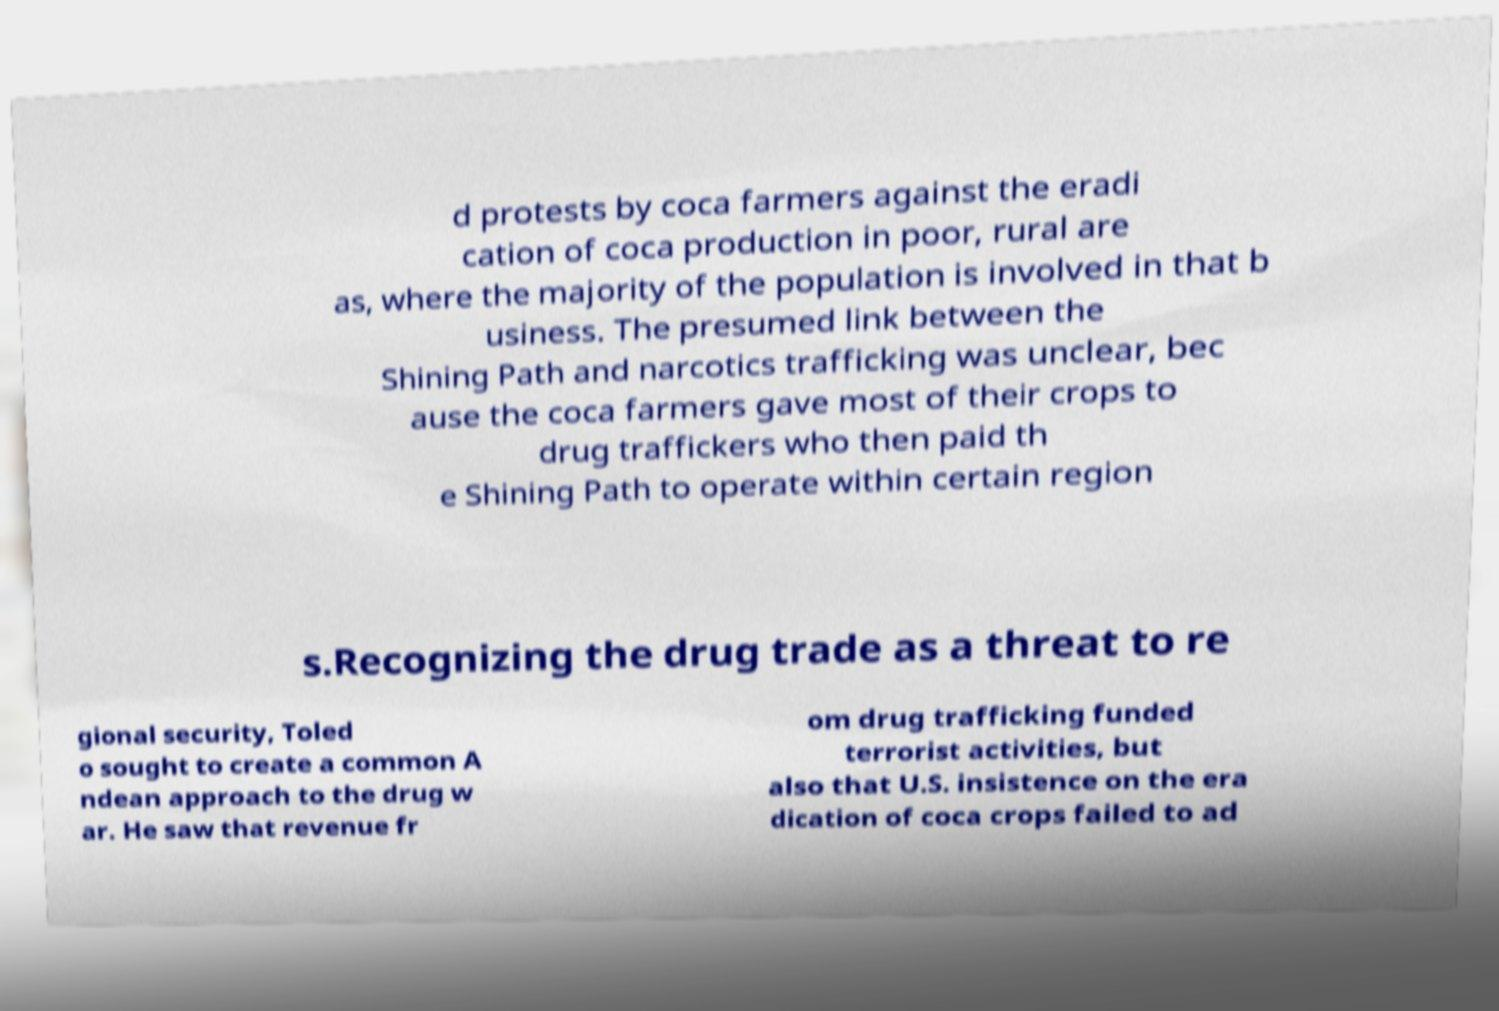Can you read and provide the text displayed in the image?This photo seems to have some interesting text. Can you extract and type it out for me? d protests by coca farmers against the eradi cation of coca production in poor, rural are as, where the majority of the population is involved in that b usiness. The presumed link between the Shining Path and narcotics trafficking was unclear, bec ause the coca farmers gave most of their crops to drug traffickers who then paid th e Shining Path to operate within certain region s.Recognizing the drug trade as a threat to re gional security, Toled o sought to create a common A ndean approach to the drug w ar. He saw that revenue fr om drug trafficking funded terrorist activities, but also that U.S. insistence on the era dication of coca crops failed to ad 